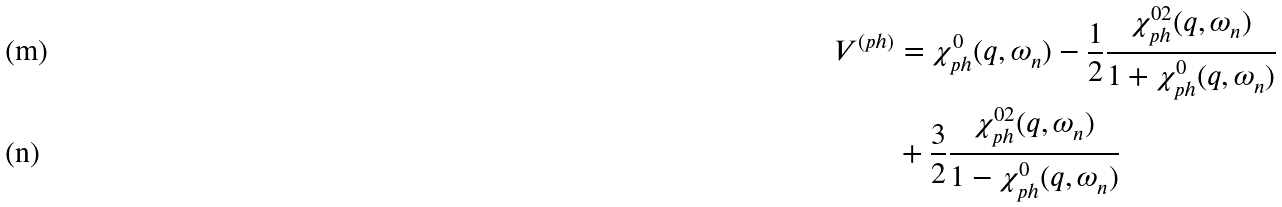<formula> <loc_0><loc_0><loc_500><loc_500>V ^ { ( p h ) } & = \chi ^ { 0 } _ { p h } ( q , \omega _ { n } ) - \frac { 1 } { 2 } \frac { \chi _ { p h } ^ { 0 2 } ( q , \omega _ { n } ) } { 1 + \chi ^ { 0 } _ { p h } ( q , \omega _ { n } ) } \\ & + \frac { 3 } { 2 } \frac { \chi _ { p h } ^ { 0 2 } ( q , \omega _ { n } ) } { 1 - \chi ^ { 0 } _ { p h } ( q , \omega _ { n } ) }</formula> 